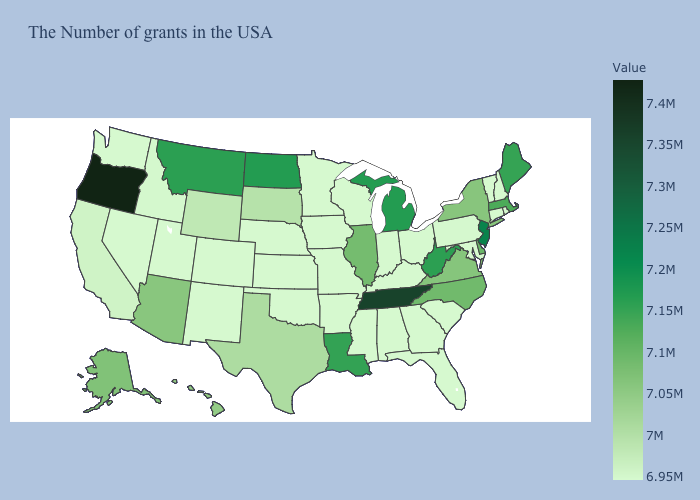Which states have the lowest value in the USA?
Give a very brief answer. Rhode Island, New Hampshire, Vermont, Connecticut, Maryland, South Carolina, Ohio, Florida, Georgia, Kentucky, Indiana, Alabama, Wisconsin, Mississippi, Missouri, Arkansas, Minnesota, Iowa, Kansas, Nebraska, Oklahoma, Colorado, New Mexico, Utah, Nevada, Washington. Which states have the lowest value in the West?
Write a very short answer. Colorado, New Mexico, Utah, Nevada, Washington. Does Indiana have the lowest value in the USA?
Give a very brief answer. Yes. Which states have the lowest value in the Northeast?
Answer briefly. Rhode Island, New Hampshire, Vermont, Connecticut. 